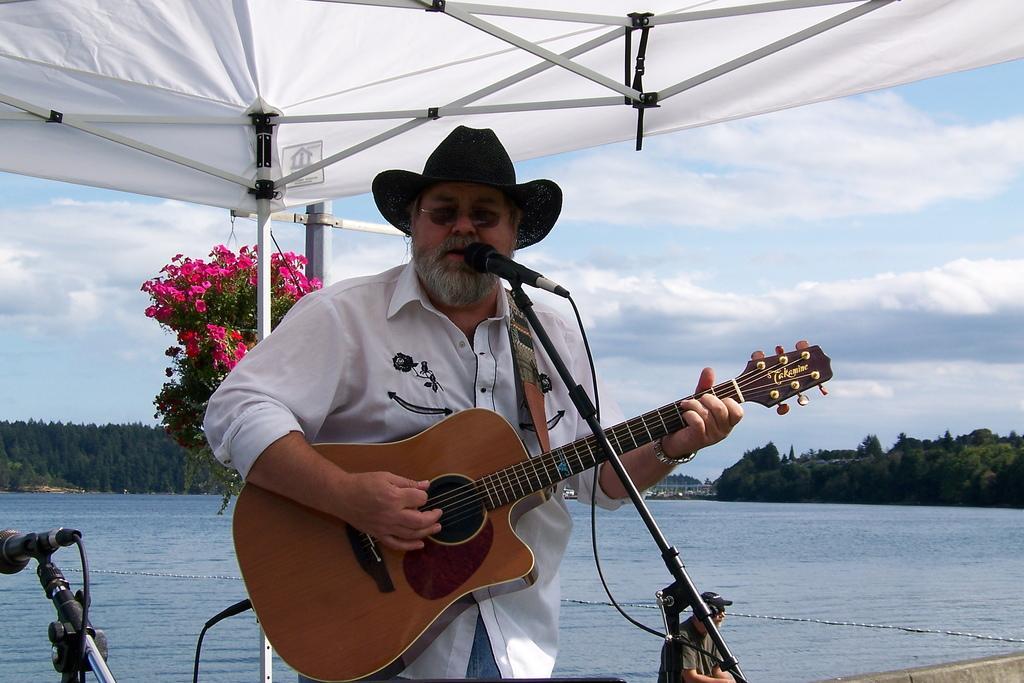Describe this image in one or two sentences. In this image i can see a person wearing a white shirt, a hat and sunglasses. He is holding a guitar in his hands and there is a microphone in front of him. In the background i can see water, trees, a cloudy sky and a person sitting. 